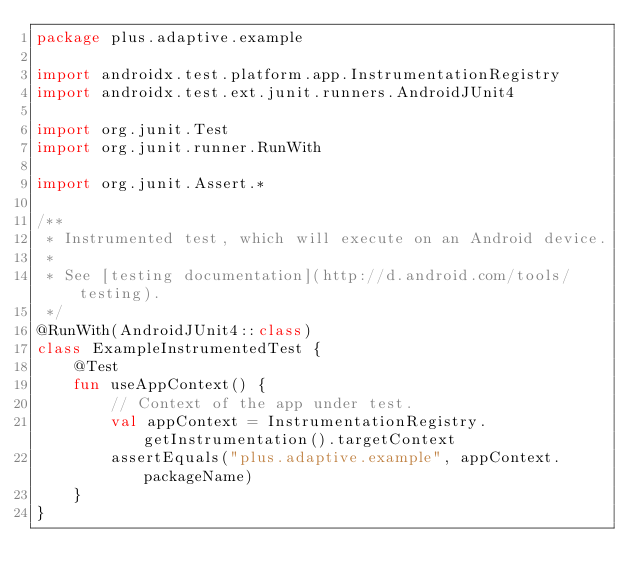<code> <loc_0><loc_0><loc_500><loc_500><_Kotlin_>package plus.adaptive.example

import androidx.test.platform.app.InstrumentationRegistry
import androidx.test.ext.junit.runners.AndroidJUnit4

import org.junit.Test
import org.junit.runner.RunWith

import org.junit.Assert.*

/**
 * Instrumented test, which will execute on an Android device.
 *
 * See [testing documentation](http://d.android.com/tools/testing).
 */
@RunWith(AndroidJUnit4::class)
class ExampleInstrumentedTest {
    @Test
    fun useAppContext() {
        // Context of the app under test.
        val appContext = InstrumentationRegistry.getInstrumentation().targetContext
        assertEquals("plus.adaptive.example", appContext.packageName)
    }
}</code> 